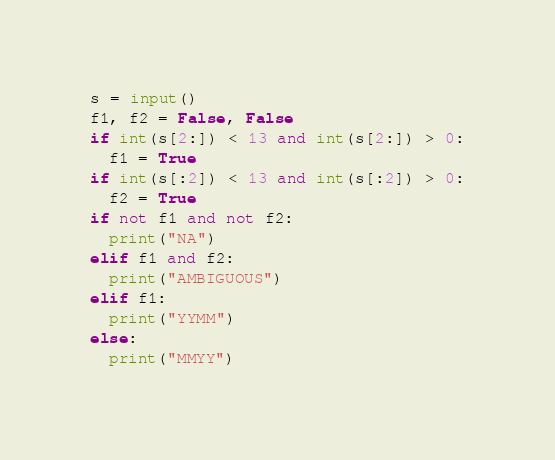<code> <loc_0><loc_0><loc_500><loc_500><_Python_>s = input()
f1, f2 = False, False
if int(s[2:]) < 13 and int(s[2:]) > 0:
  f1 = True
if int(s[:2]) < 13 and int(s[:2]) > 0:
  f2 = True
if not f1 and not f2:
  print("NA")
elif f1 and f2:
  print("AMBIGUOUS")
elif f1:
  print("YYMM")
else:
  print("MMYY")
</code> 